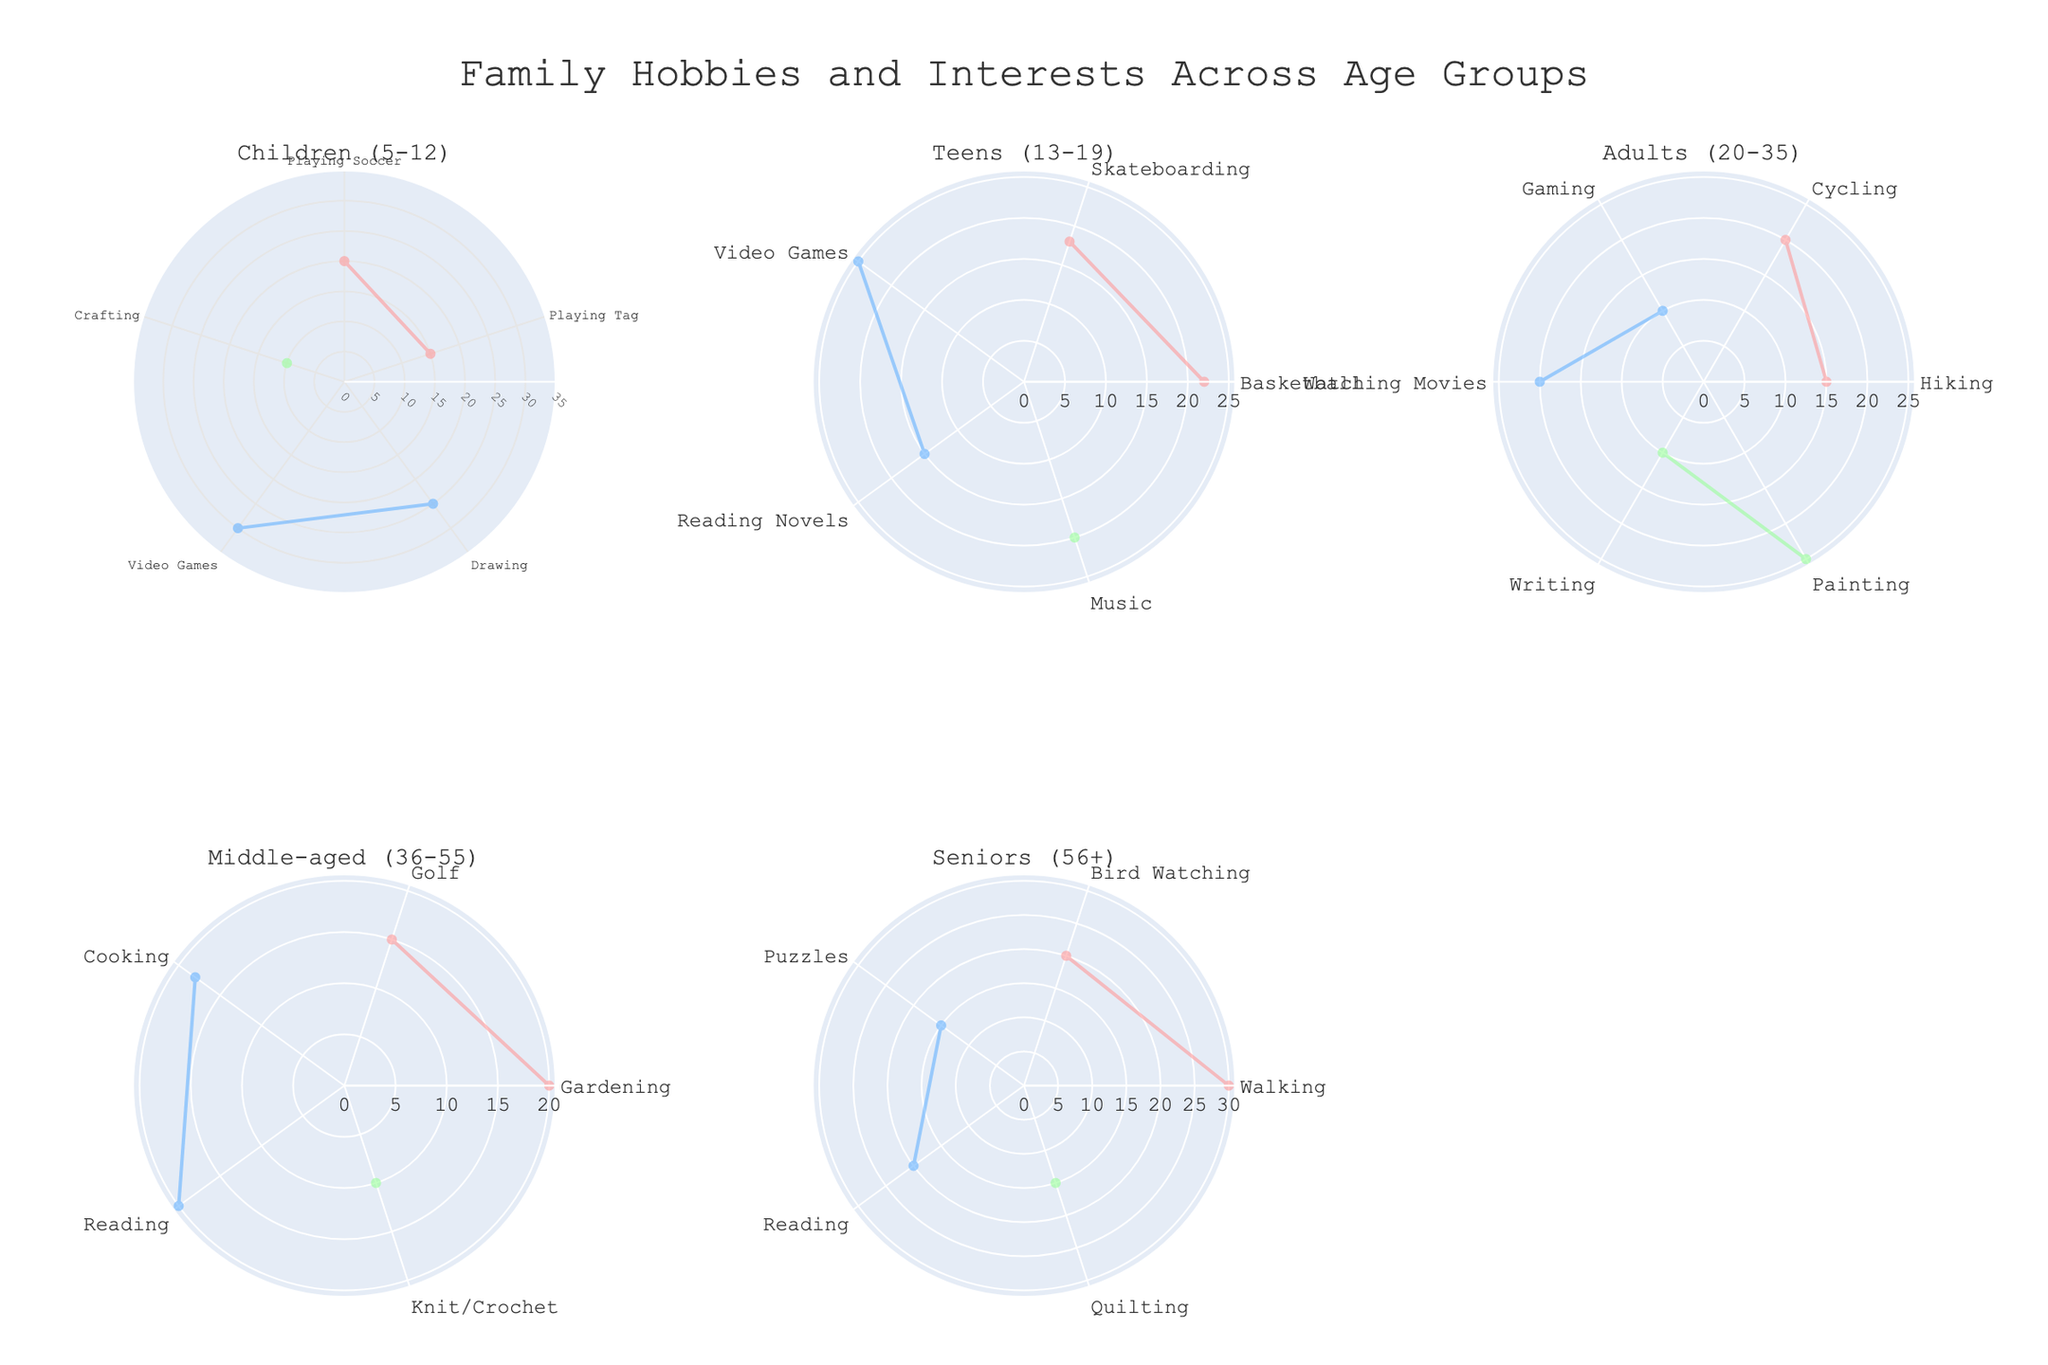What is the most popular hobby among children aged 5-12? To determine the most popular hobby among children aged 5-12, we look at the segment with the highest percentage in the subplot corresponding to that age group, which is Video Games with 30%.
Answer: Video Games Which age group shows the highest interest in creative hobbies like painting and writing? By examining each subplot, the age group 'Adults (20-35)' shows a high percentage for creative hobbies, with Painting at 25%.
Answer: Adults (20-35) How does the popularity of reading novels change from teens to seniors? The polar chart shows that Reading Novels is 15% among teens and remains significant for middle-aged and seniors with a value of around 20%. This demonstrates a consistent interest in reading across these age groups.
Answer: Increases What percentage of middle-aged individuals enjoy gardening? Checking the Middle-aged (36-55) subplot, Gardening is represented as 20%.
Answer: 20% Which age group has the least interest in crafting? For crafting, which falls under 'Creative' hobbies, the Children (5-12) group has the only data point for Crafting with a 10% interest, which is the lowest compared to other creative hobbies in other age groups.
Answer: Children (5-12) Does any age group show an interest in both outdoor and indoor hobbies equally? The subplot for each age group needs to be analyzed for comparing indoor versus outdoor activities. The 'Adults (20-35)' age group shows almost equal percentages for outdoor (15% for Hiking, 20% for Cycling) and indoor (20% for Watching Movies, 10% for Gaming) activities.
Answer: Adults (20-35) In the teens age group, which indoor interest is more popular: Video Games or Reading Novels? By checking the teens' subplot for indoor hobbies, we see that Video Games have 25% and Reading Novels have 15%. Hence, Video Games are more popular.
Answer: Video Games What is the least popular interest among seniors aged 56+? Inspect the seniors' subplot to find the segment with the lowest percentage, which is Puzzles at 15%.
Answer: Puzzles Between middle-aged individuals and seniors, which group has a higher interest in outdoor hobbies? Comparing the highest percentages in the outdoor category, Middle-aged individuals and Seniors enjoy outdoor hobbies at 20% and 30%, respectively. Seniors have a higher interest.
Answer: Seniors Are there any categories where one age group's interest exceeds 30%? Examining all subplots, the only interest to exceed 30% is Walking among seniors, at 30%.
Answer: Yes, Walking for Seniors 